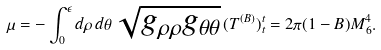<formula> <loc_0><loc_0><loc_500><loc_500>\mu = - \int _ { 0 } ^ { \epsilon } d \rho \, d \theta \, \sqrt { g _ { \rho \rho } g _ { \theta \theta } } \, ( T ^ { ( B ) } ) ^ { t } _ { t } = 2 \pi ( 1 - B ) M _ { 6 } ^ { 4 } .</formula> 